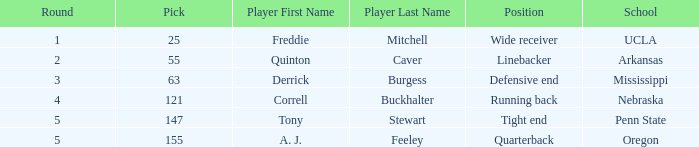What is the sum of rounds where freddie mitchell was picked? 1.0. 